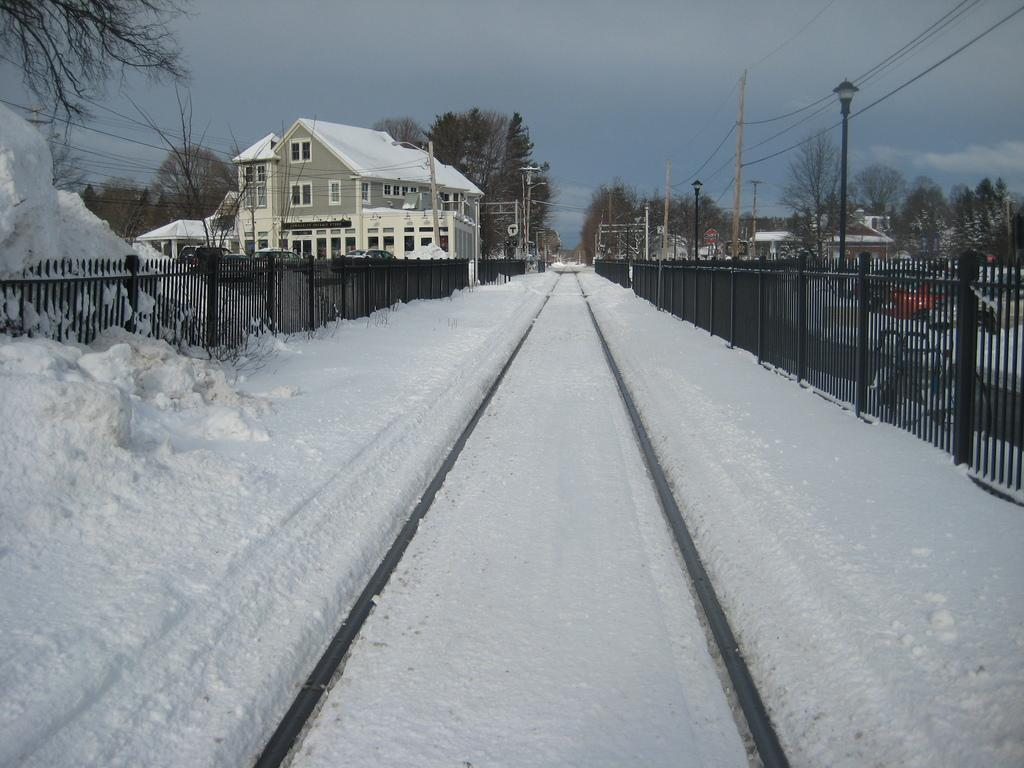What type of structures can be seen in the image? There are buildings with windows in the image. What natural elements are present in the image? There are trees in the image. What man-made elements can be seen in the image? There is a fence, poles, and wires in the image. What is the weather like in the image? There is snow in the image, which suggests a cold or wintery weather. What is visible in the background of the image? The sky with clouds is visible in the background of the image. How many cows are grazing in the yard in the image? There are no cows or yards present in the image. What type of cap is the person wearing in the image? There are no people or caps present in the image. 